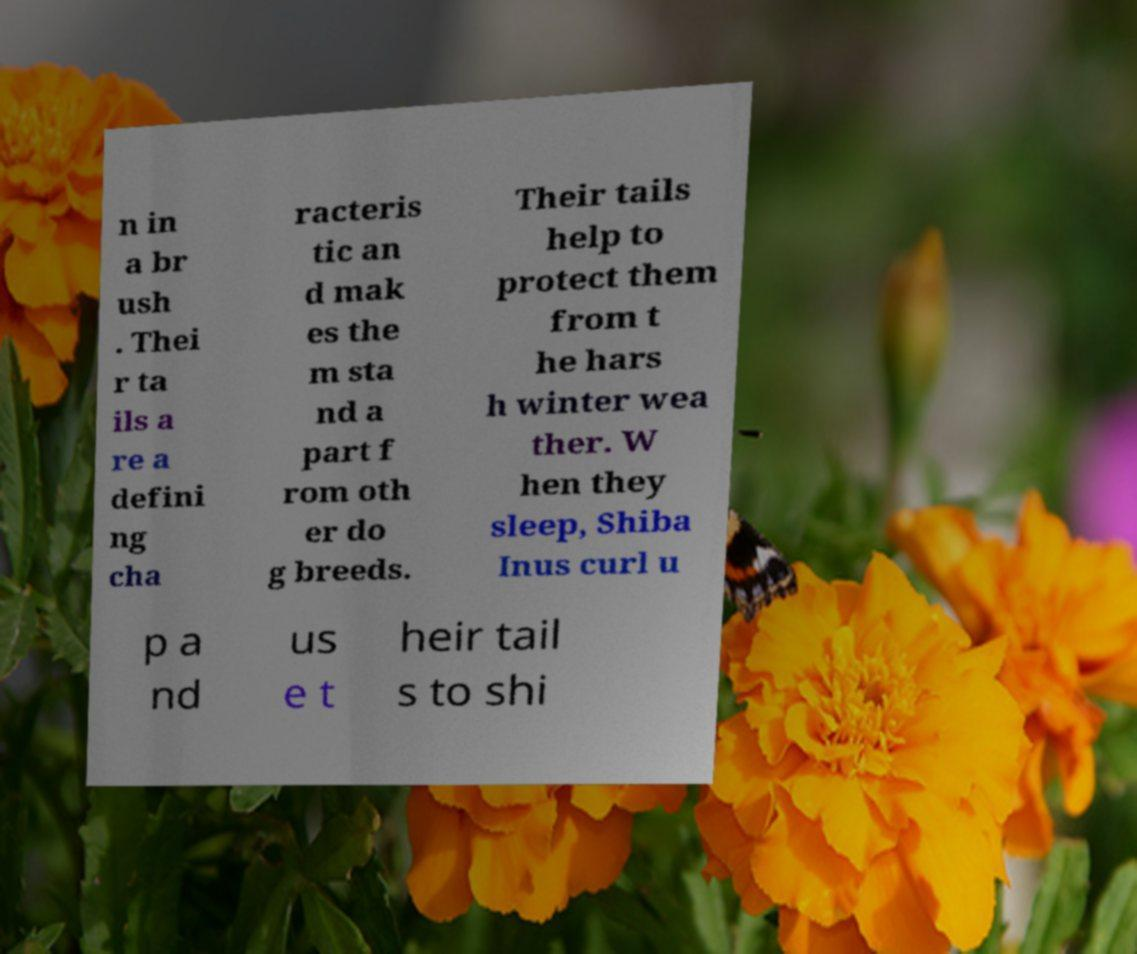I need the written content from this picture converted into text. Can you do that? n in a br ush . Thei r ta ils a re a defini ng cha racteris tic an d mak es the m sta nd a part f rom oth er do g breeds. Their tails help to protect them from t he hars h winter wea ther. W hen they sleep, Shiba Inus curl u p a nd us e t heir tail s to shi 